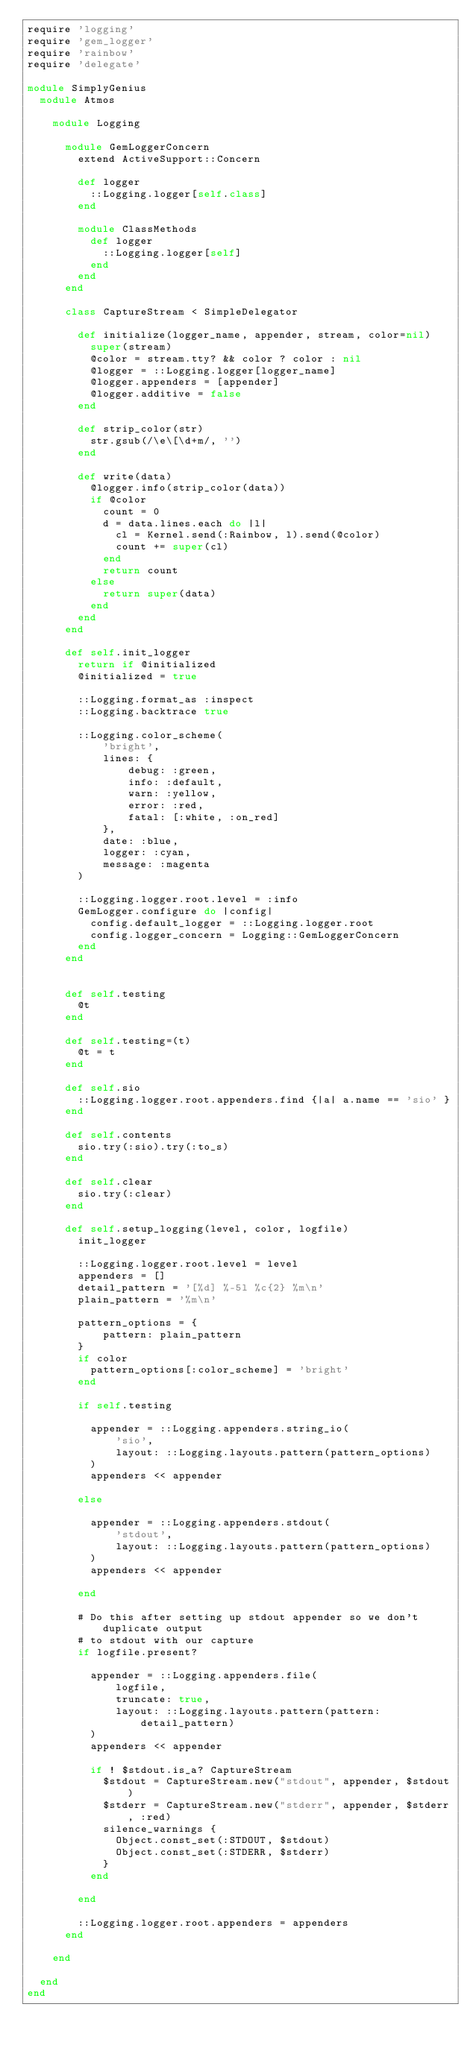Convert code to text. <code><loc_0><loc_0><loc_500><loc_500><_Ruby_>require 'logging'
require 'gem_logger'
require 'rainbow'
require 'delegate'

module SimplyGenius
  module Atmos

    module Logging

      module GemLoggerConcern
        extend ActiveSupport::Concern

        def logger
          ::Logging.logger[self.class]
        end

        module ClassMethods
          def logger
            ::Logging.logger[self]
          end
        end
      end

      class CaptureStream < SimpleDelegator

        def initialize(logger_name, appender, stream, color=nil)
          super(stream)
          @color = stream.tty? && color ? color : nil
          @logger = ::Logging.logger[logger_name]
          @logger.appenders = [appender]
          @logger.additive = false
        end

        def strip_color(str)
          str.gsub(/\e\[\d+m/, '')
        end

        def write(data)
          @logger.info(strip_color(data))
          if @color
            count = 0
            d = data.lines.each do |l|
              cl = Kernel.send(:Rainbow, l).send(@color)
              count += super(cl)
            end
            return count
          else
            return super(data)
          end
        end
      end

      def self.init_logger
        return if @initialized
        @initialized = true

        ::Logging.format_as :inspect
        ::Logging.backtrace true

        ::Logging.color_scheme(
            'bright',
            lines: {
                debug: :green,
                info: :default,
                warn: :yellow,
                error: :red,
                fatal: [:white, :on_red]
            },
            date: :blue,
            logger: :cyan,
            message: :magenta
        )

        ::Logging.logger.root.level = :info
        GemLogger.configure do |config|
          config.default_logger = ::Logging.logger.root
          config.logger_concern = Logging::GemLoggerConcern
        end
      end


      def self.testing
        @t
      end

      def self.testing=(t)
        @t = t
      end

      def self.sio
        ::Logging.logger.root.appenders.find {|a| a.name == 'sio' }
      end

      def self.contents
        sio.try(:sio).try(:to_s)
      end

      def self.clear
        sio.try(:clear)
      end

      def self.setup_logging(level, color, logfile)
        init_logger

        ::Logging.logger.root.level = level
        appenders = []
        detail_pattern = '[%d] %-5l %c{2} %m\n'
        plain_pattern = '%m\n'

        pattern_options = {
            pattern: plain_pattern
        }
        if color
          pattern_options[:color_scheme] = 'bright'
        end

        if self.testing

          appender = ::Logging.appenders.string_io(
              'sio',
              layout: ::Logging.layouts.pattern(pattern_options)
          )
          appenders << appender

        else

          appender = ::Logging.appenders.stdout(
              'stdout',
              layout: ::Logging.layouts.pattern(pattern_options)
          )
          appenders << appender

        end

        # Do this after setting up stdout appender so we don't duplicate output
        # to stdout with our capture
        if logfile.present?

          appender = ::Logging.appenders.file(
              logfile,
              truncate: true,
              layout: ::Logging.layouts.pattern(pattern: detail_pattern)
          )
          appenders << appender

          if ! $stdout.is_a? CaptureStream
            $stdout = CaptureStream.new("stdout", appender, $stdout)
            $stderr = CaptureStream.new("stderr", appender, $stderr, :red)
            silence_warnings {
              Object.const_set(:STDOUT, $stdout)
              Object.const_set(:STDERR, $stderr)
            }
          end

        end

        ::Logging.logger.root.appenders = appenders
      end

    end

  end
end
</code> 